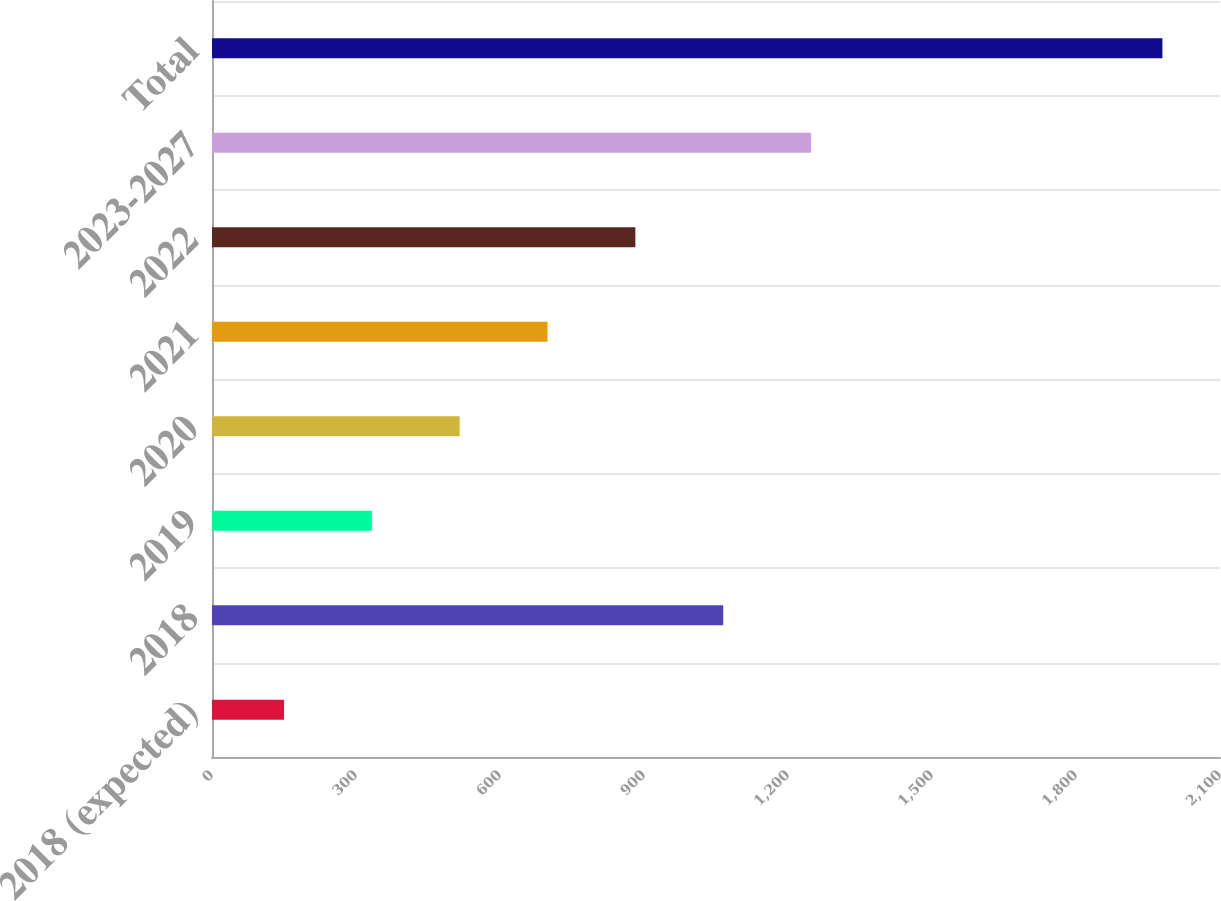Convert chart to OTSL. <chart><loc_0><loc_0><loc_500><loc_500><bar_chart><fcel>2018 (expected)<fcel>2018<fcel>2019<fcel>2020<fcel>2021<fcel>2022<fcel>2023-2027<fcel>Total<nl><fcel>150<fcel>1065<fcel>333<fcel>516<fcel>699<fcel>882<fcel>1248<fcel>1980<nl></chart> 